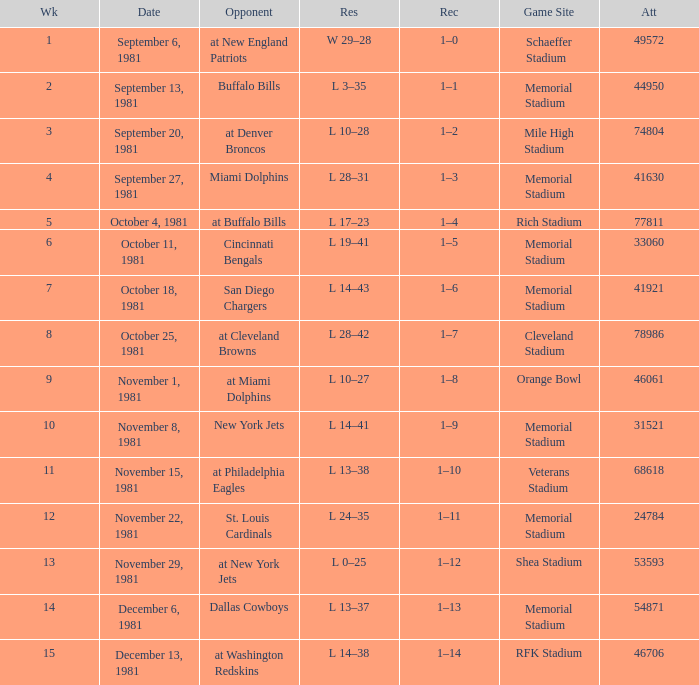When it is October 18, 1981 where is the game site? Memorial Stadium. 